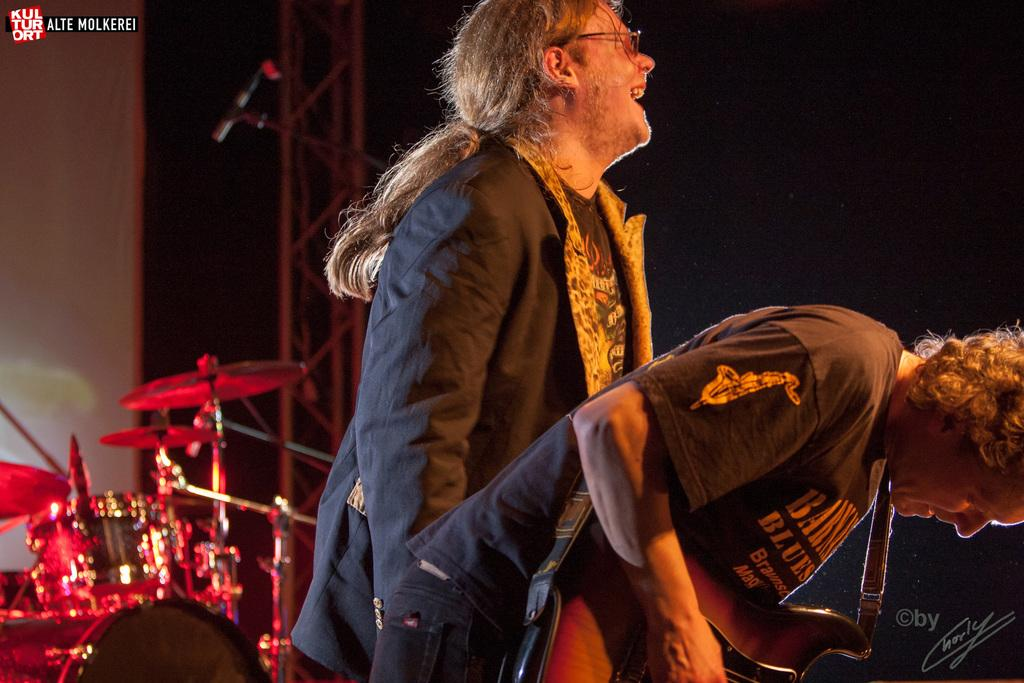How many people are in the image? There are two persons in the image. What is one person doing in the image? One person is playing a guitar. How can you describe the expression of the other person? The other person is smiling. What accessory is the smiling person wearing? The smiling person is wearing spectacles. What musical instrument can be seen in the background of the image? There are drums in the background of the image. How many ants can be seen crawling on the guitar in the image? There are no ants visible in the image, and therefore none can be seen crawling on the guitar. What type of soap is being used by the person playing the guitar in the image? There is no soap present in the image, and the person playing the guitar is not using any soap. 